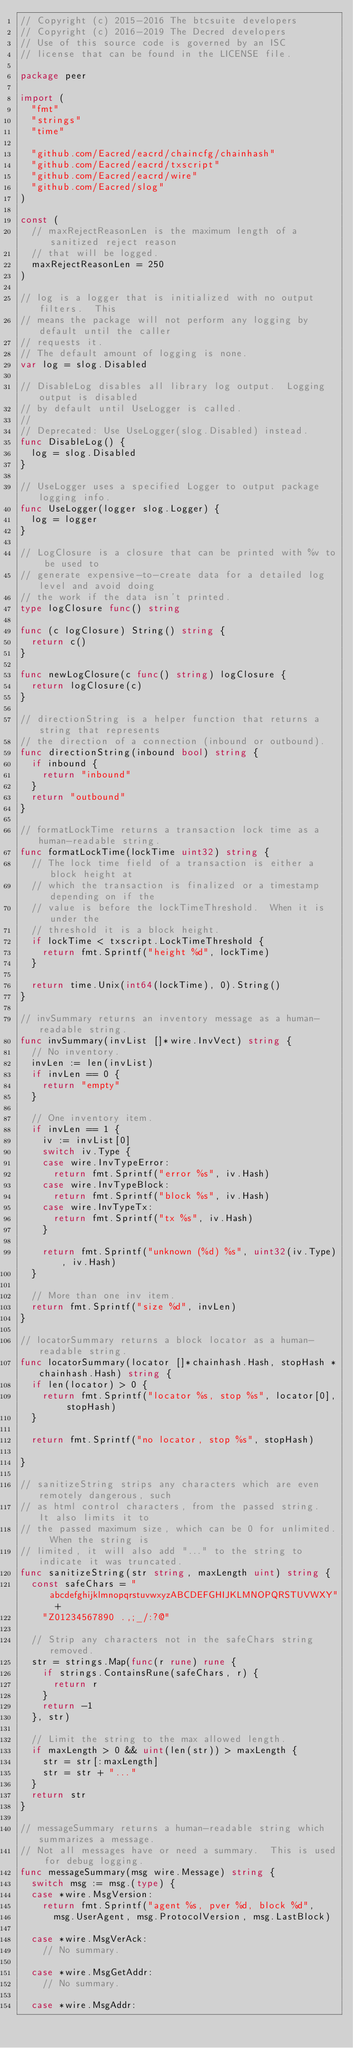<code> <loc_0><loc_0><loc_500><loc_500><_Go_>// Copyright (c) 2015-2016 The btcsuite developers
// Copyright (c) 2016-2019 The Decred developers
// Use of this source code is governed by an ISC
// license that can be found in the LICENSE file.

package peer

import (
	"fmt"
	"strings"
	"time"

	"github.com/Eacred/eacrd/chaincfg/chainhash"
	"github.com/Eacred/eacrd/txscript"
	"github.com/Eacred/eacrd/wire"
	"github.com/Eacred/slog"
)

const (
	// maxRejectReasonLen is the maximum length of a sanitized reject reason
	// that will be logged.
	maxRejectReasonLen = 250
)

// log is a logger that is initialized with no output filters.  This
// means the package will not perform any logging by default until the caller
// requests it.
// The default amount of logging is none.
var log = slog.Disabled

// DisableLog disables all library log output.  Logging output is disabled
// by default until UseLogger is called.
//
// Deprecated: Use UseLogger(slog.Disabled) instead.
func DisableLog() {
	log = slog.Disabled
}

// UseLogger uses a specified Logger to output package logging info.
func UseLogger(logger slog.Logger) {
	log = logger
}

// LogClosure is a closure that can be printed with %v to be used to
// generate expensive-to-create data for a detailed log level and avoid doing
// the work if the data isn't printed.
type logClosure func() string

func (c logClosure) String() string {
	return c()
}

func newLogClosure(c func() string) logClosure {
	return logClosure(c)
}

// directionString is a helper function that returns a string that represents
// the direction of a connection (inbound or outbound).
func directionString(inbound bool) string {
	if inbound {
		return "inbound"
	}
	return "outbound"
}

// formatLockTime returns a transaction lock time as a human-readable string.
func formatLockTime(lockTime uint32) string {
	// The lock time field of a transaction is either a block height at
	// which the transaction is finalized or a timestamp depending on if the
	// value is before the lockTimeThreshold.  When it is under the
	// threshold it is a block height.
	if lockTime < txscript.LockTimeThreshold {
		return fmt.Sprintf("height %d", lockTime)
	}

	return time.Unix(int64(lockTime), 0).String()
}

// invSummary returns an inventory message as a human-readable string.
func invSummary(invList []*wire.InvVect) string {
	// No inventory.
	invLen := len(invList)
	if invLen == 0 {
		return "empty"
	}

	// One inventory item.
	if invLen == 1 {
		iv := invList[0]
		switch iv.Type {
		case wire.InvTypeError:
			return fmt.Sprintf("error %s", iv.Hash)
		case wire.InvTypeBlock:
			return fmt.Sprintf("block %s", iv.Hash)
		case wire.InvTypeTx:
			return fmt.Sprintf("tx %s", iv.Hash)
		}

		return fmt.Sprintf("unknown (%d) %s", uint32(iv.Type), iv.Hash)
	}

	// More than one inv item.
	return fmt.Sprintf("size %d", invLen)
}

// locatorSummary returns a block locator as a human-readable string.
func locatorSummary(locator []*chainhash.Hash, stopHash *chainhash.Hash) string {
	if len(locator) > 0 {
		return fmt.Sprintf("locator %s, stop %s", locator[0], stopHash)
	}

	return fmt.Sprintf("no locator, stop %s", stopHash)

}

// sanitizeString strips any characters which are even remotely dangerous, such
// as html control characters, from the passed string.  It also limits it to
// the passed maximum size, which can be 0 for unlimited.  When the string is
// limited, it will also add "..." to the string to indicate it was truncated.
func sanitizeString(str string, maxLength uint) string {
	const safeChars = "abcdefghijklmnopqrstuvwxyzABCDEFGHIJKLMNOPQRSTUVWXY" +
		"Z01234567890 .,;_/:?@"

	// Strip any characters not in the safeChars string removed.
	str = strings.Map(func(r rune) rune {
		if strings.ContainsRune(safeChars, r) {
			return r
		}
		return -1
	}, str)

	// Limit the string to the max allowed length.
	if maxLength > 0 && uint(len(str)) > maxLength {
		str = str[:maxLength]
		str = str + "..."
	}
	return str
}

// messageSummary returns a human-readable string which summarizes a message.
// Not all messages have or need a summary.  This is used for debug logging.
func messageSummary(msg wire.Message) string {
	switch msg := msg.(type) {
	case *wire.MsgVersion:
		return fmt.Sprintf("agent %s, pver %d, block %d",
			msg.UserAgent, msg.ProtocolVersion, msg.LastBlock)

	case *wire.MsgVerAck:
		// No summary.

	case *wire.MsgGetAddr:
		// No summary.

	case *wire.MsgAddr:</code> 